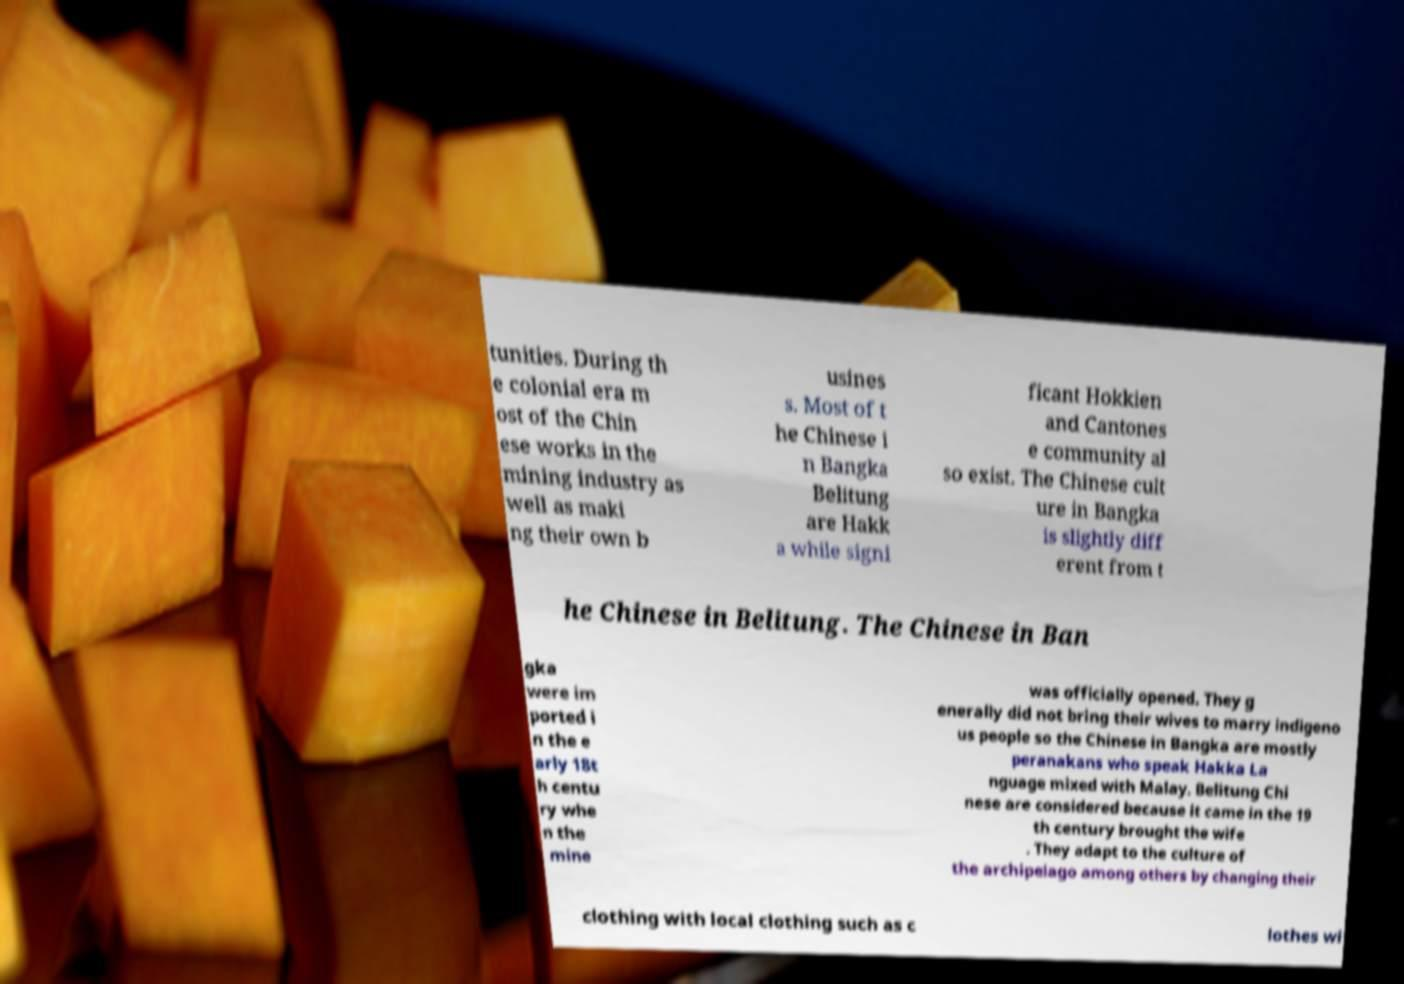For documentation purposes, I need the text within this image transcribed. Could you provide that? tunities. During th e colonial era m ost of the Chin ese works in the mining industry as well as maki ng their own b usines s. Most of t he Chinese i n Bangka Belitung are Hakk a while signi ficant Hokkien and Cantones e community al so exist. The Chinese cult ure in Bangka is slightly diff erent from t he Chinese in Belitung. The Chinese in Ban gka were im ported i n the e arly 18t h centu ry whe n the mine was officially opened. They g enerally did not bring their wives to marry indigeno us people so the Chinese in Bangka are mostly peranakans who speak Hakka La nguage mixed with Malay. Belitung Chi nese are considered because it came in the 19 th century brought the wife . They adapt to the culture of the archipelago among others by changing their clothing with local clothing such as c lothes wi 